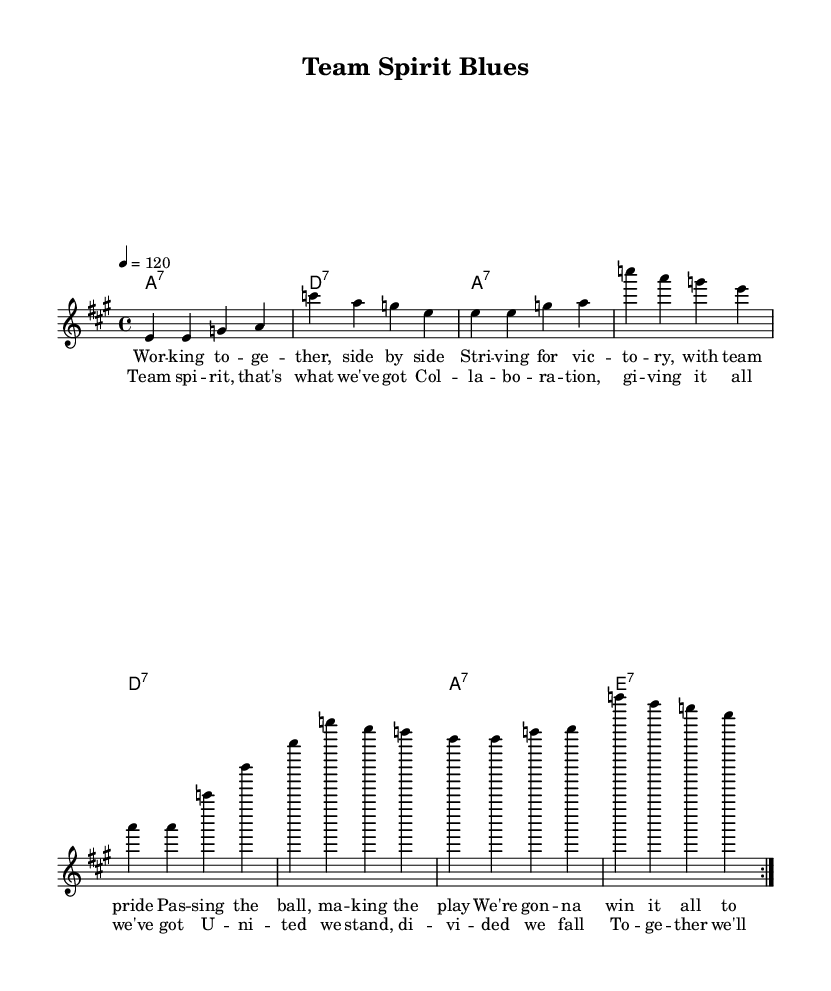What is the key signature of this music? The key signature is A major, which has three sharps: F#, C#, and G#. This is indicated at the beginning of the sheet music.
Answer: A major What is the time signature of this music? The time signature is 4/4, meaning there are four beats in each measure and the quarter note gets one beat. This is shown in the notation at the start of the music.
Answer: 4/4 What is the tempo marking for this piece? The tempo marking indicates a speed of 120 beats per minute, which is specified in the initial markings of the sheet music.
Answer: 120 How many measures are in the melody? The melody consists of eight measures, which can be counted by reviewing each grouped set of notes separated by bar lines in the staff.
Answer: Eight What is the main theme of the lyrics? The main theme of the lyrics celebrates teamwork and collaboration in sports, as reflected in phrases about working together and pride in victory.
Answer: Teamwork What chords are used in the chorus section? The chords used in the chorus are A7, D7, and E7, which can be identified in the chord symbols above the lyrics that accompany the chorus section.
Answer: A7, D7, E7 How does the melody of the chorus compare to the verse? The melody of the chorus has a more uplifting and celebratory feel, emphasized by the repeated rhythms and higher notes, unlike the more narrative style of the verse.
Answer: Uplifting 